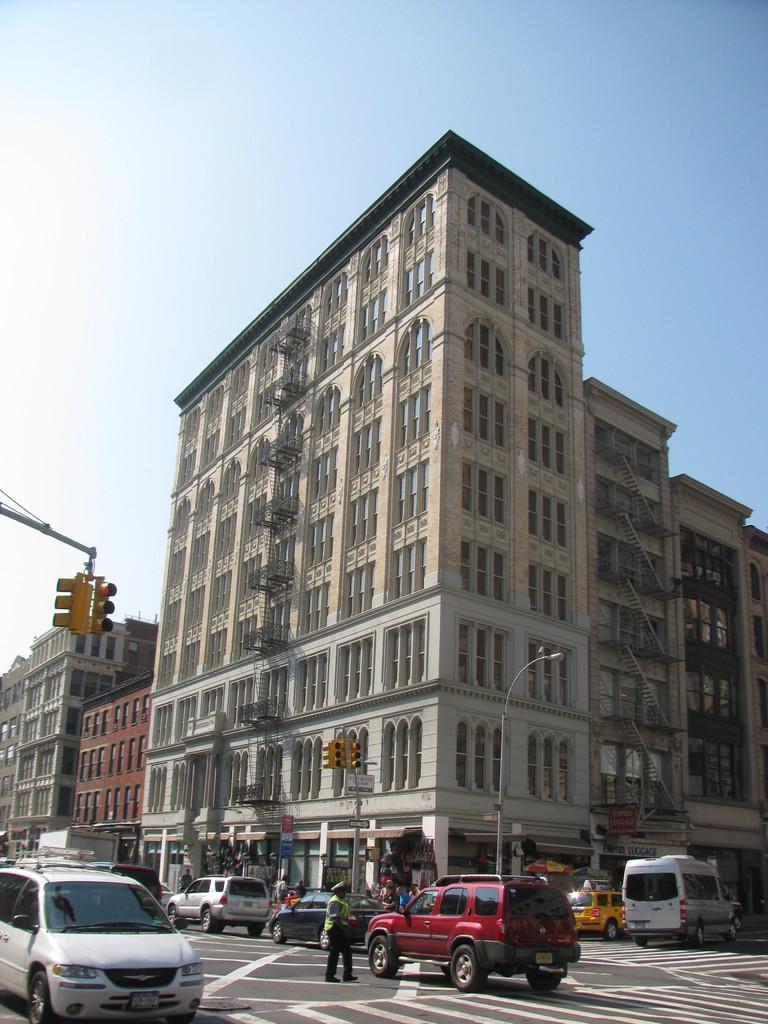Could you give a brief overview of what you see in this image? As we can see in the image there are buildings, traffic signals, few people here and there and on road there are vehicles. On the top there is sky. 